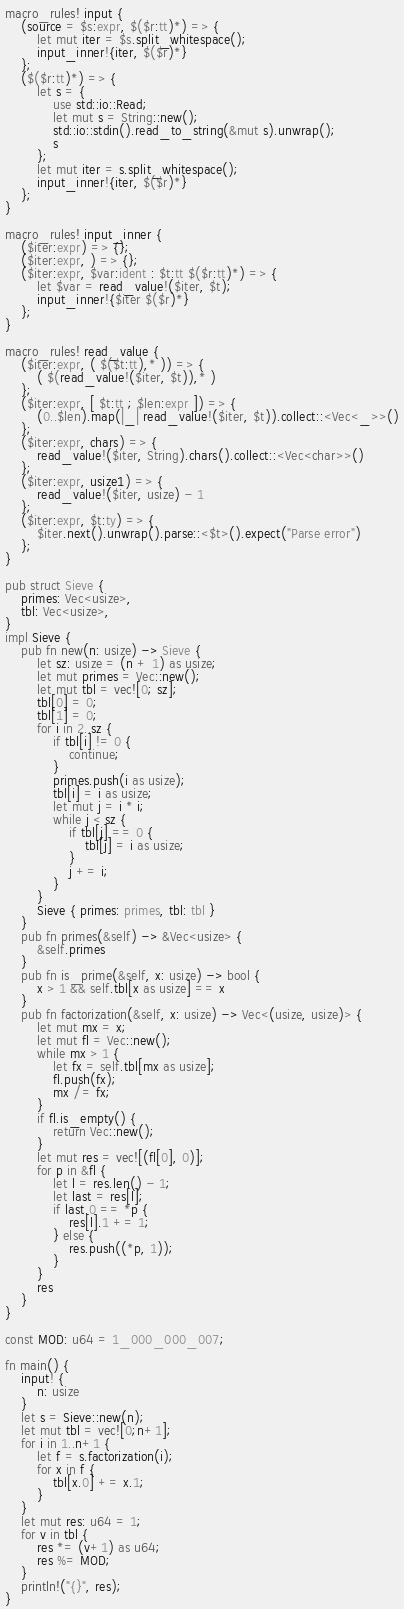<code> <loc_0><loc_0><loc_500><loc_500><_Rust_>macro_rules! input {
    (source = $s:expr, $($r:tt)*) => {
        let mut iter = $s.split_whitespace();
        input_inner!{iter, $($r)*}
    };
    ($($r:tt)*) => {
        let s = {
            use std::io::Read;
            let mut s = String::new();
            std::io::stdin().read_to_string(&mut s).unwrap();
            s
        };
        let mut iter = s.split_whitespace();
        input_inner!{iter, $($r)*}
    };
}

macro_rules! input_inner {
    ($iter:expr) => {};
    ($iter:expr, ) => {};
    ($iter:expr, $var:ident : $t:tt $($r:tt)*) => {
        let $var = read_value!($iter, $t);
        input_inner!{$iter $($r)*}
    };
}

macro_rules! read_value {
    ($iter:expr, ( $($t:tt),* )) => {
        ( $(read_value!($iter, $t)),* )
    };
    ($iter:expr, [ $t:tt ; $len:expr ]) => {
        (0..$len).map(|_| read_value!($iter, $t)).collect::<Vec<_>>()
    };
    ($iter:expr, chars) => {
        read_value!($iter, String).chars().collect::<Vec<char>>()
    };
    ($iter:expr, usize1) => {
        read_value!($iter, usize) - 1
    };
    ($iter:expr, $t:ty) => {
        $iter.next().unwrap().parse::<$t>().expect("Parse error")
    };
}

pub struct Sieve {
    primes: Vec<usize>,
    tbl: Vec<usize>,
}
impl Sieve {
    pub fn new(n: usize) -> Sieve {
        let sz: usize = (n + 1) as usize;
        let mut primes = Vec::new();
        let mut tbl = vec![0; sz];
        tbl[0] = 0;
        tbl[1] = 0;
        for i in 2..sz {
            if tbl[i] != 0 {
                continue;
            }
            primes.push(i as usize);
            tbl[i] = i as usize;
            let mut j = i * i;
            while j < sz {
                if tbl[j] == 0 {
                    tbl[j] = i as usize;
                }
                j += i;
            }
        }
        Sieve { primes: primes, tbl: tbl }
    }
    pub fn primes(&self) -> &Vec<usize> {
        &self.primes
    }
    pub fn is_prime(&self, x: usize) -> bool {
        x > 1 && self.tbl[x as usize] == x
    }
    pub fn factorization(&self, x: usize) -> Vec<(usize, usize)> {
        let mut mx = x;
        let mut fl = Vec::new();
        while mx > 1 {
            let fx = self.tbl[mx as usize];
            fl.push(fx);
            mx /= fx;
        }
        if fl.is_empty() {
            return Vec::new();
        }
        let mut res = vec![(fl[0], 0)];
        for p in &fl {
            let l = res.len() - 1;
            let last = res[l];
            if last.0 == *p {
                res[l].1 += 1;
            } else {
                res.push((*p, 1));
            }
        }
        res
    }
}

const MOD: u64 = 1_000_000_007;

fn main() {
    input! {
        n: usize
    }
    let s = Sieve::new(n);
    let mut tbl = vec![0;n+1];
    for i in 1..n+1 {
        let f = s.factorization(i);
        for x in f {
            tbl[x.0] += x.1;
        }
    }
    let mut res: u64 = 1;
    for v in tbl {
        res *= (v+1) as u64;
        res %= MOD;
    }
    println!("{}", res);
}
</code> 